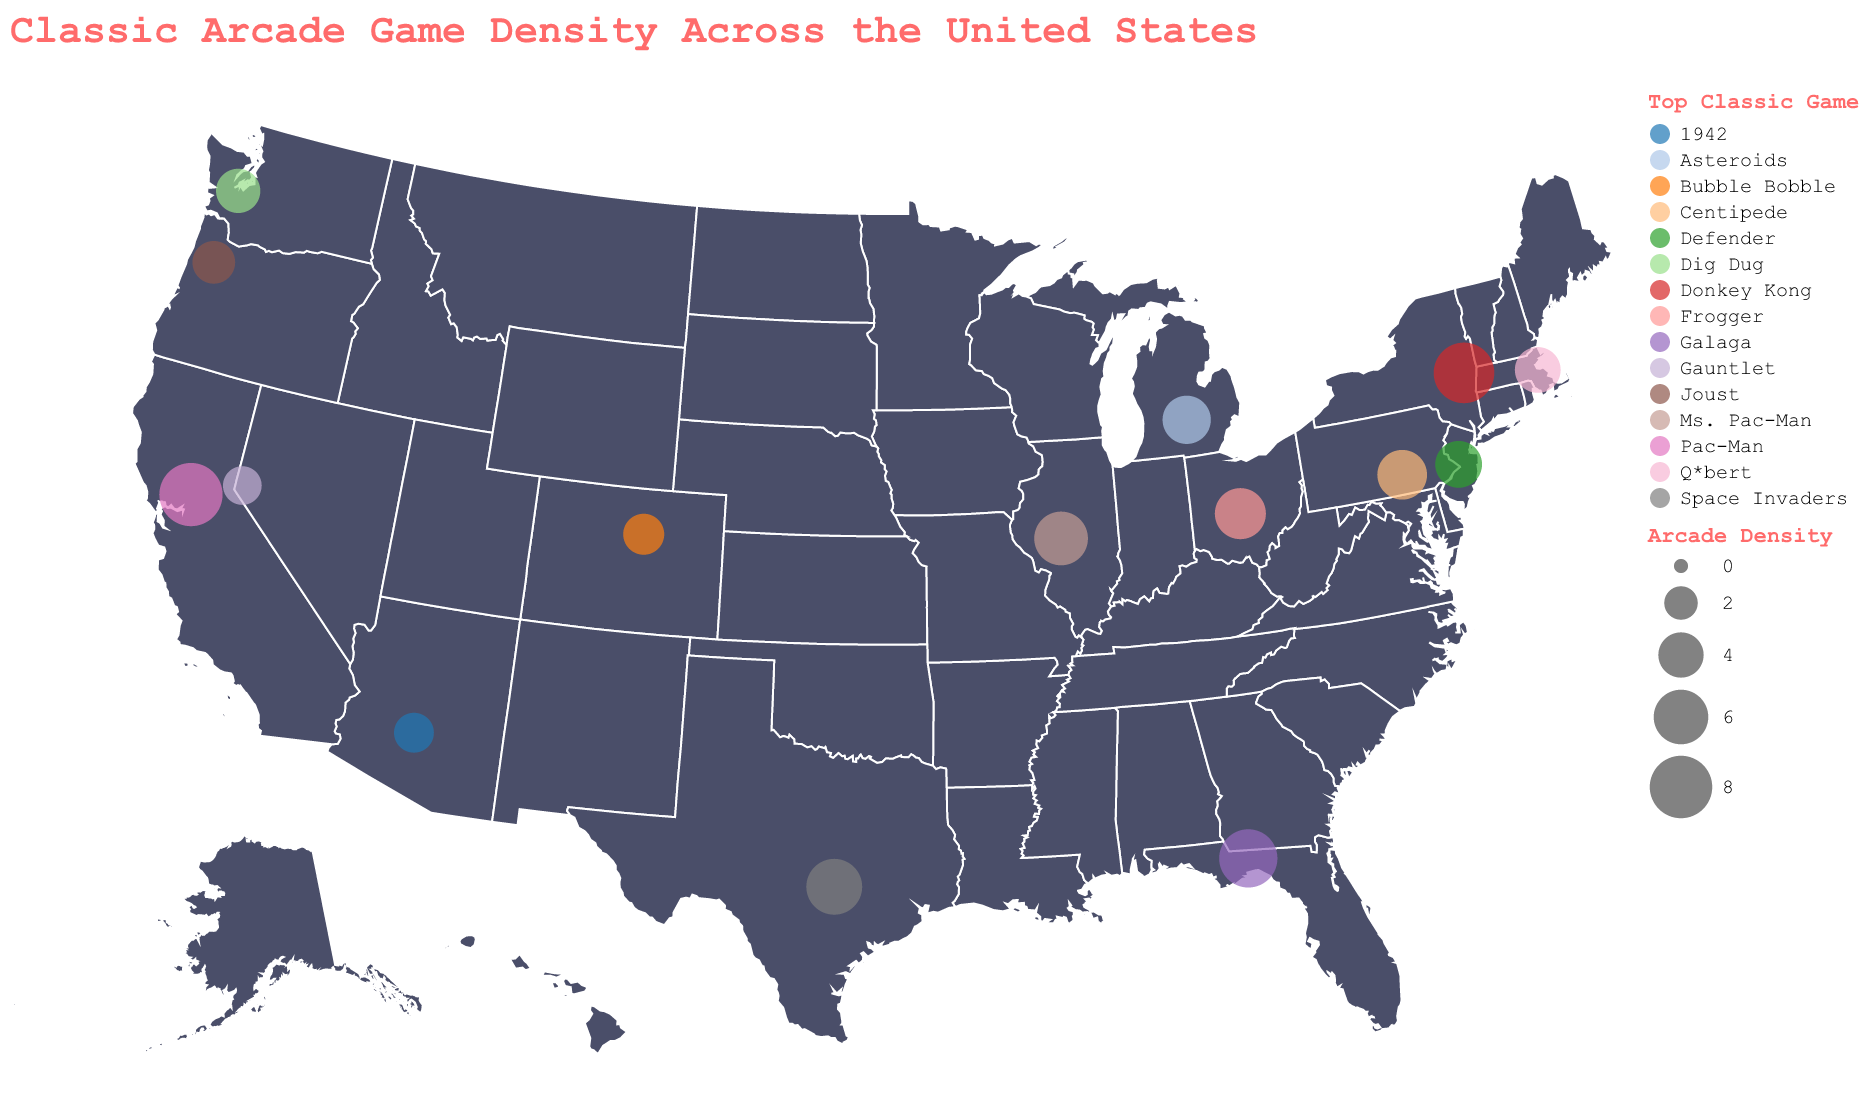Which state has the highest arcade density? The title indicates arcade density is a key measure. The circles plotted on California show the largest size, indicating the highest density.
Answer: California What is the top classic game in New York? The tooltip would show the top classic game for New York when hovered over. The cirle for New York indicates Donkey Kong as the top game.
Answer: Donkey Kong Which state has a higher arcade density, Texas or Florida? By comparing the state circles, Texas has a smaller circle than Florida, indicating a lower density.
Answer: Florida What is the average arcade density of the top three states? The top three states (California, New York, Florida) have densities of 8.2, 7.5, and 6.9, respectively. Average = (8.2 + 7.5 + 6.9) / 3 = 7.53
Answer: 7.53 What is the state with the lowest arcade density? By observing the smallest circles, Nevada's is the smallest, indicating the lowest density.
Answer: Nevada Which state has "Pac-Man" as the top classic game? The tooltip for the largest circle, representing California, shows Pac-Man as the top classic game.
Answer: California What is the difference in arcade density between Illinois and Ohio? The densities for Illinois is 5.8 and for Ohio is 5.2. Difference = 5.8 - 5.2 = 0.6
Answer: 0.6 What is the top classic game in Michigan? The tooltip for the circle representing Michigan indicates "Asteroids" as the top game.
Answer: Asteroids Which states have an arcade density greater than 5? By evaluating the circles, the states California, New York, Florida, Texas, Illinois, and Ohio have densities above 5.
Answer: California, New York, Florida, Texas, Illinois, Ohio What color represents "Space Invaders" on the map? Observing the color in the legend associated with "Space Invaders", and cross-referencing the Texas plot point shows its designated color.
Answer: [Color from legend] 